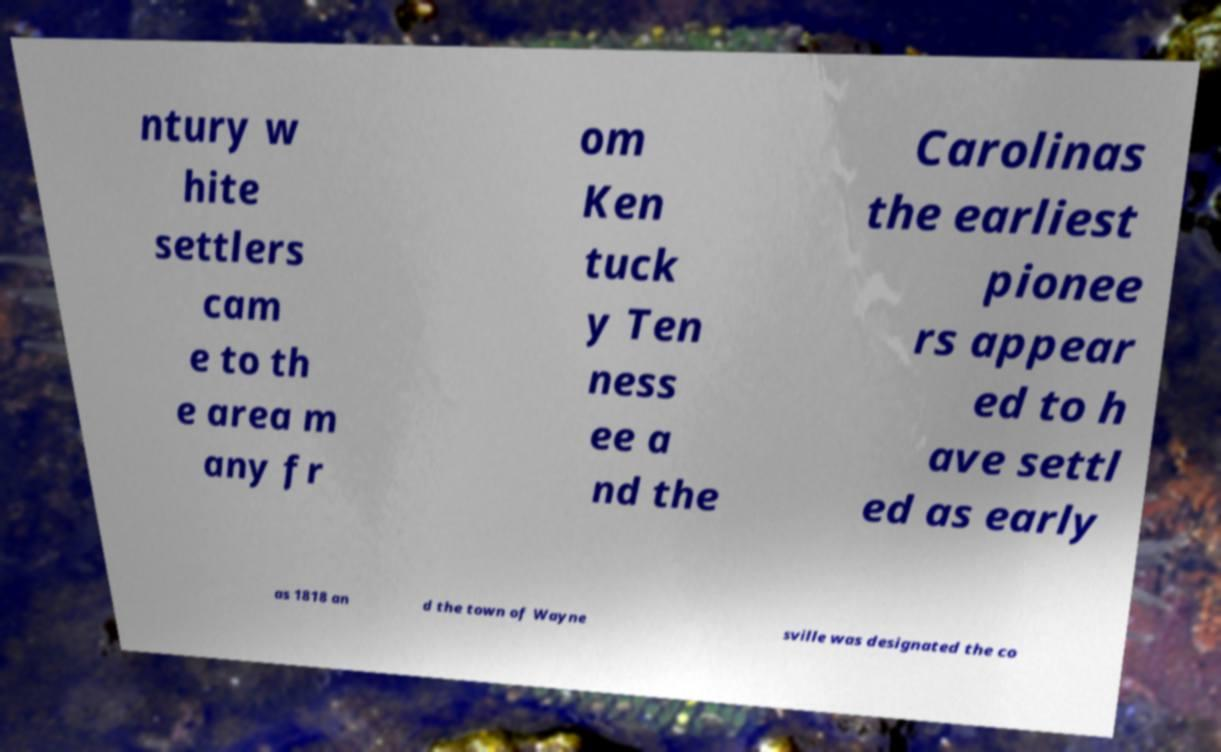Could you extract and type out the text from this image? ntury w hite settlers cam e to th e area m any fr om Ken tuck y Ten ness ee a nd the Carolinas the earliest pionee rs appear ed to h ave settl ed as early as 1818 an d the town of Wayne sville was designated the co 